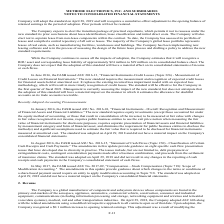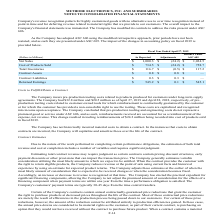According to Methode Electronics's financial document, What is the retained earnings as reported in 2019? According to the financial document, $545.2 (in millions). The relevant text states: "Retained Earnings $ 545.2 $ 0.1 $ 545.1..." Also, What was the increase in opening retained earnings post adoption? According to the financial document, $0.1 million. The relevant text states: "that date. Upon adoption, the Company recognized a $0.1 million increase to opening retained earnings. This adjustment was a result of modifying the..." Also, What was the net sales as reported and under ASC 605 respectively? The document shows two values: 1,000.3 and 1,024.5 (in millions). From the document: "Net Sales $ 1,000.3 $ (24.2) $ 1,024.5 Net Sales $ 1,000.3 $ (24.2) $ 1,024.5..." Also, can you calculate: What percentage of net sales was retained earnings as reported? Based on the calculation: 545.2 / 1,000.3, the result is 54.5 (percentage). This is based on the information: "Net Sales $ 1,000.3 $ (24.2) $ 1,024.5 Retained Earnings $ 545.2 $ 0.1 $ 545.1..." The key data points involved are: 1,000.3, 545.2. Also, can you calculate: What was the percentage of adjustment in cost of products sold as reported? Based on the calculation: 24.2 / 734.5, the result is 3.29 (percentage). This is based on the information: "Net Sales $ 1,000.3 $ (24.2) $ 1,024.5 Cost of Products Sold $ 734.5 $ (24.2) $ 758.7..." The key data points involved are: 24.2, 734.5. Also, can you calculate: What percentage of retained earnings was total inventories as reported? Based on the calculation: 116.7 / 545.2, the result is 21.4 (percentage). This is based on the information: "Total Inventories $ 116.7 $ (0.5) $ 117.2 Retained Earnings $ 545.2 $ 0.1 $ 545.1..." The key data points involved are: 116.7, 545.2. 